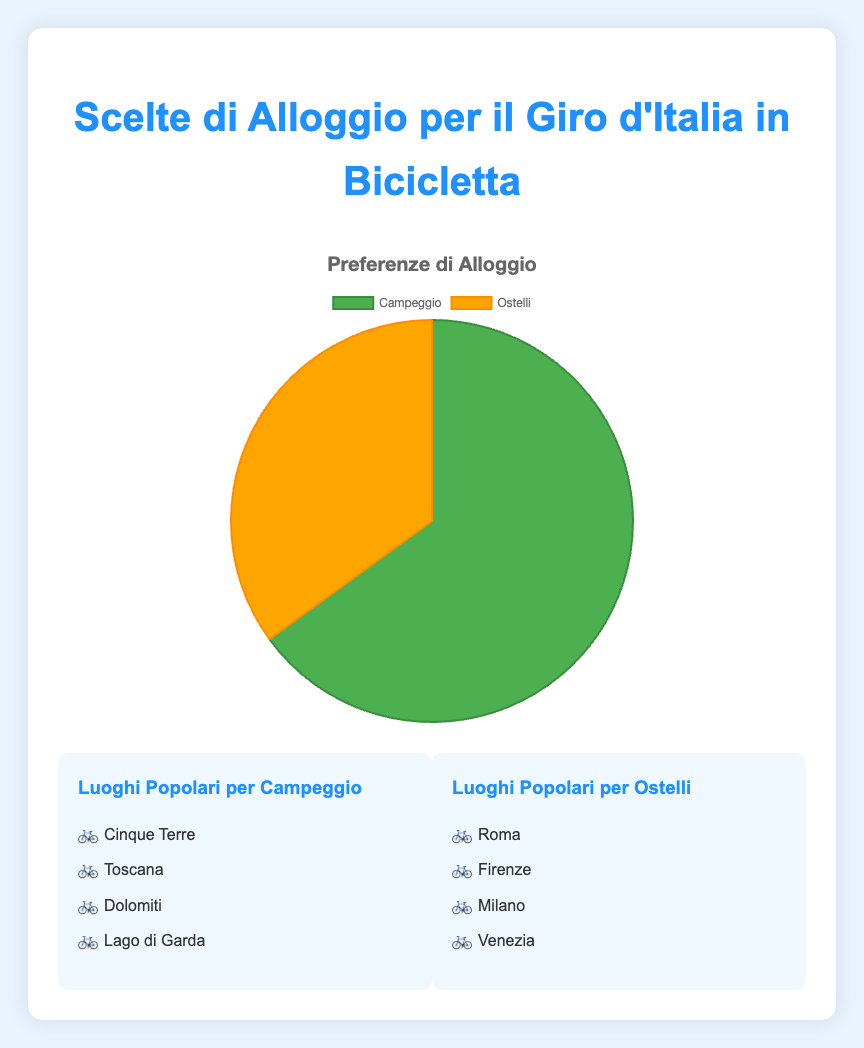Which accommodation type is preferred by the majority? The pie chart shows two segments, 'Camping' and 'Hostels'. The 'Camping' segment is larger. Thus, it indicates that camping is preferred by the majority.
Answer: Camping What percentage of accommodation choices is for camping? The legend next to the pie chart indicates that 'Camping' represents 65% of the accommodation choices.
Answer: 65% Calculate the difference in preference percentages between camping and hostels. According to the chart, 'Camping' is preferred by 65% and 'Hostels' by 35%. The difference is calculated as 65% - 35% = 30%.
Answer: 30% Which color represents hostels in the pie chart? The pie chart uses color coding to distinguish between 'Camping' and 'Hostels'. The segment representing 'Hostels' is colored in orange.
Answer: Orange List the popular locations for camping. The chart legend and accompanying descriptions provide a breakdown. Some popular locations for camping are Cinque Terre, Tuscany, Dolomites, and Lake Garda.
Answer: Cinque Terre, Tuscany, Dolomites, Lake Garda Is the portion representing hostels more than camping? The pie chart displays that 'Camping' has a larger segment than 'Hostels'. Therefore, the portion representing hostels is not more than camping.
Answer: No What are the combined locations popular for both camping and hostels? Looking at the lists of popular locations for both types, the combined locations are Cinque Terre, Tuscany, Dolomites, Lake Garda, Rome, Florence, Milan, and Venice.
Answer: Cinque Terre, Tuscany, Dolomites, Lake Garda, Rome, Florence, Milan, Venice What is the ratio of preferences for camping versus hostels? From the chart, camping is preferred by 65% and hostels by 35%. The ratio of camping to hostels can be calculated as 65:35, which simplifies to 13:7.
Answer: 13:7 In which location is camping particularly popular according to the chart? The locations shown for camping include Cinque Terre, Tuscany, Dolomites, and Lake Garda. Based on the chart, camping is particularly popular in these locations.
Answer: Cinque Terre, Tuscany, Dolomites, Lake Garda 